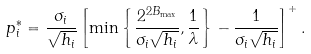<formula> <loc_0><loc_0><loc_500><loc_500>p _ { i } ^ { * } = \frac { \sigma _ { i } } { \sqrt { h _ { i } } } \left [ \min \left \{ { \frac { 2 ^ { 2 B _ { \max } } } { \sigma _ { i } \sqrt { h _ { i } } } } , \frac { 1 } { \lambda } \right \} - \frac { 1 } { \sigma _ { i } \sqrt { h _ { i } } } \right ] ^ { + } .</formula> 